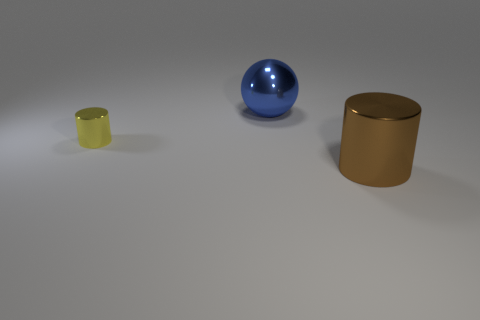Add 1 brown shiny objects. How many objects exist? 4 Subtract all cylinders. How many objects are left? 1 Subtract 0 blue blocks. How many objects are left? 3 Subtract all large objects. Subtract all large cylinders. How many objects are left? 0 Add 2 large blue metallic spheres. How many large blue metallic spheres are left? 3 Add 1 metallic balls. How many metallic balls exist? 2 